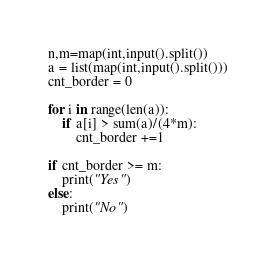Convert code to text. <code><loc_0><loc_0><loc_500><loc_500><_Python_>n,m=map(int,input().split())
a = list(map(int,input().split()))
cnt_border = 0

for i in range(len(a)):
    if a[i] > sum(a)/(4*m):
        cnt_border +=1
        
if cnt_border >= m:
    print("Yes")
else:
    print("No")</code> 